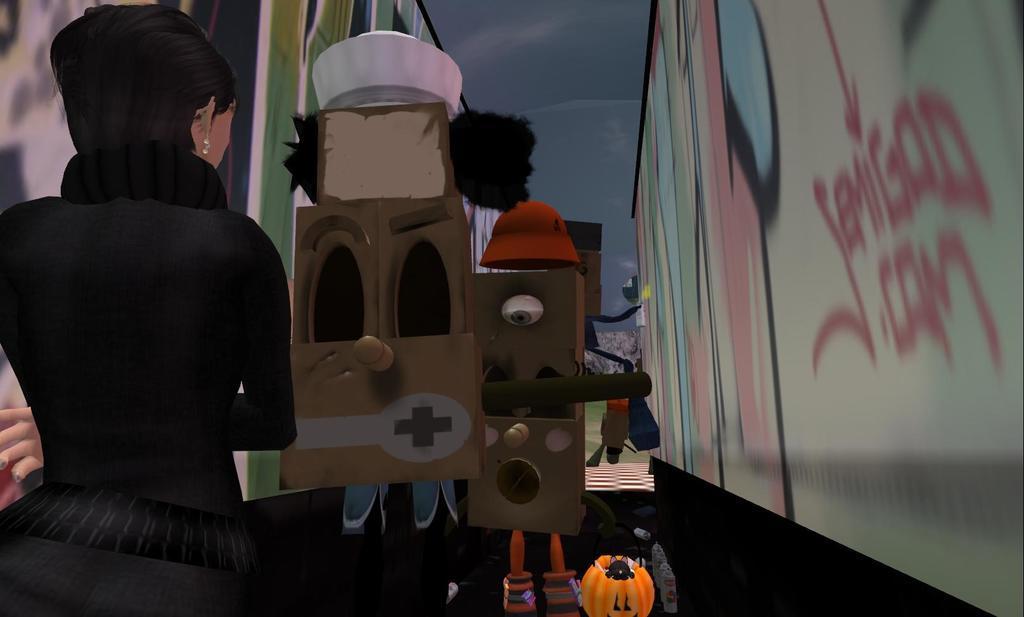Can you describe this image briefly? In the image we can see there is an animation picture in which there is a woman standing and in front of her there are robot toys standing on the ground. There are wall and there is graffiti done on the wall. 